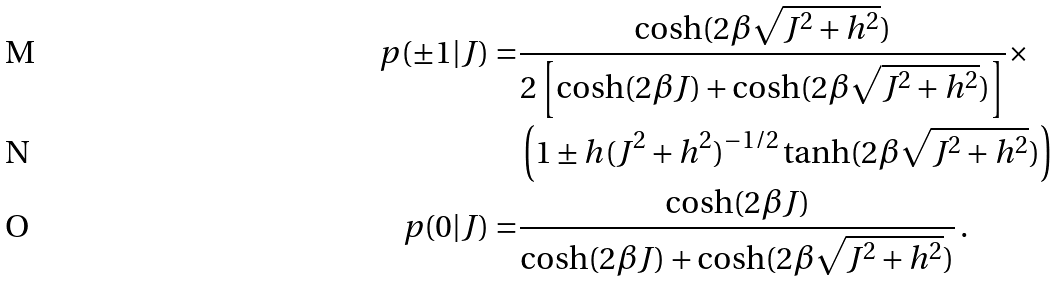Convert formula to latex. <formula><loc_0><loc_0><loc_500><loc_500>p ( \pm 1 | J ) = & \frac { \cosh ( 2 \beta \sqrt { J ^ { 2 } + h ^ { 2 } } ) } { 2 \left [ \cosh ( 2 \beta J ) + \cosh ( 2 \beta \sqrt { J ^ { 2 } + h ^ { 2 } } ) \right ] } \times \\ & \left ( 1 \pm h ( J ^ { 2 } + h ^ { 2 } ) ^ { - 1 / 2 } \tanh ( 2 \beta \sqrt { J ^ { 2 } + h ^ { 2 } } ) \right ) \\ p ( 0 | J ) = & \frac { \cosh ( 2 \beta J ) } { \cosh ( 2 \beta J ) + \cosh ( 2 \beta \sqrt { J ^ { 2 } + h ^ { 2 } } ) } \, .</formula> 